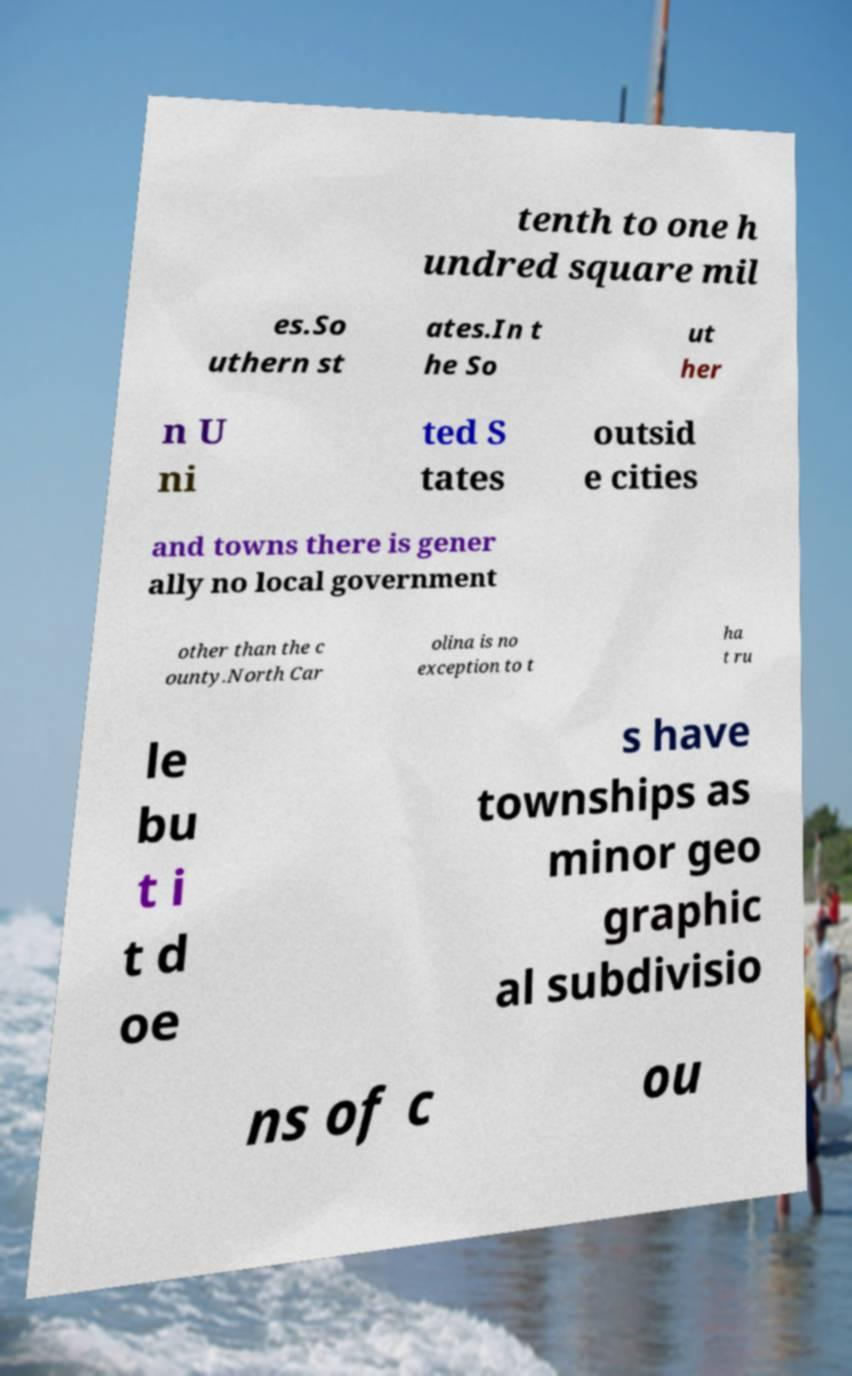What messages or text are displayed in this image? I need them in a readable, typed format. tenth to one h undred square mil es.So uthern st ates.In t he So ut her n U ni ted S tates outsid e cities and towns there is gener ally no local government other than the c ounty.North Car olina is no exception to t ha t ru le bu t i t d oe s have townships as minor geo graphic al subdivisio ns of c ou 